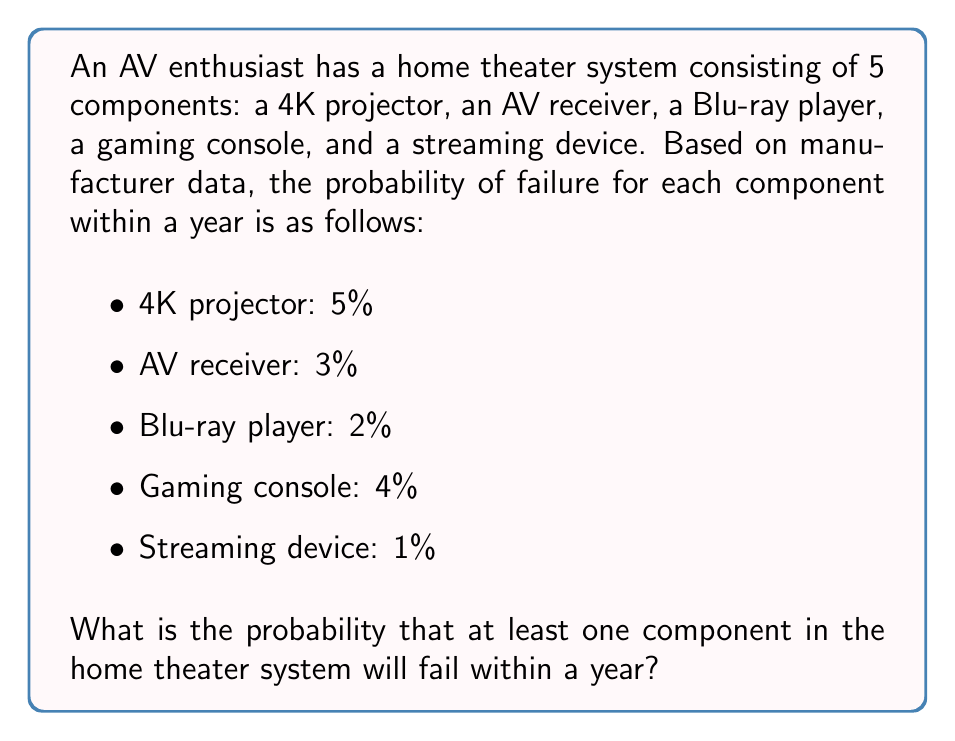Solve this math problem. To solve this problem, we'll use the complement rule of probability. Instead of calculating the probability of at least one component failing, we'll calculate the probability of no components failing and then subtract that from 1.

Let's follow these steps:

1. Calculate the probability of each component not failing:
   - 4K projector: $1 - 0.05 = 0.95$
   - AV receiver: $1 - 0.03 = 0.97$
   - Blu-ray player: $1 - 0.02 = 0.98$
   - Gaming console: $1 - 0.04 = 0.96$
   - Streaming device: $1 - 0.01 = 0.99$

2. Calculate the probability of all components not failing:
   $$P(\text{no failures}) = 0.95 \times 0.97 \times 0.98 \times 0.96 \times 0.99 = 0.8583$$

3. Use the complement rule to find the probability of at least one component failing:
   $$P(\text{at least one failure}) = 1 - P(\text{no failures})$$
   $$P(\text{at least one failure}) = 1 - 0.8583 = 0.1417$$

4. Convert to a percentage:
   $$0.1417 \times 100\% = 14.17\%$$

Therefore, the probability that at least one component in the home theater system will fail within a year is approximately 14.17%.
Answer: 14.17% 